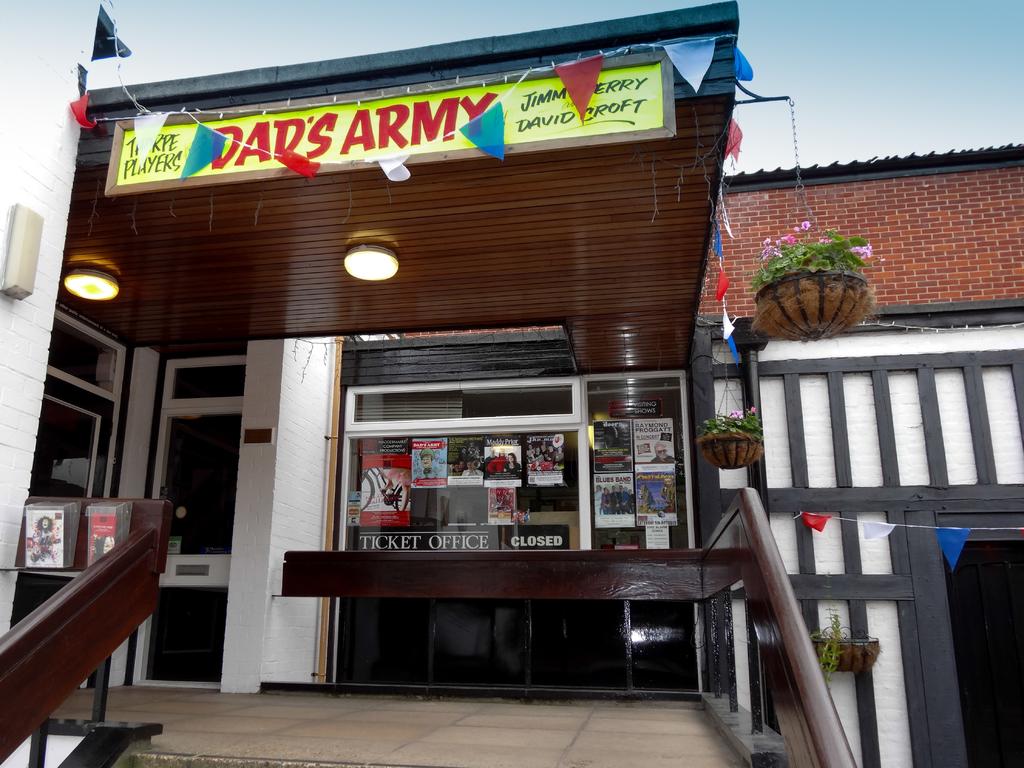What kind of office is this?
Keep it short and to the point. Ticket office. Whose army does the yellow board refer to?
Offer a very short reply. Dad's. 